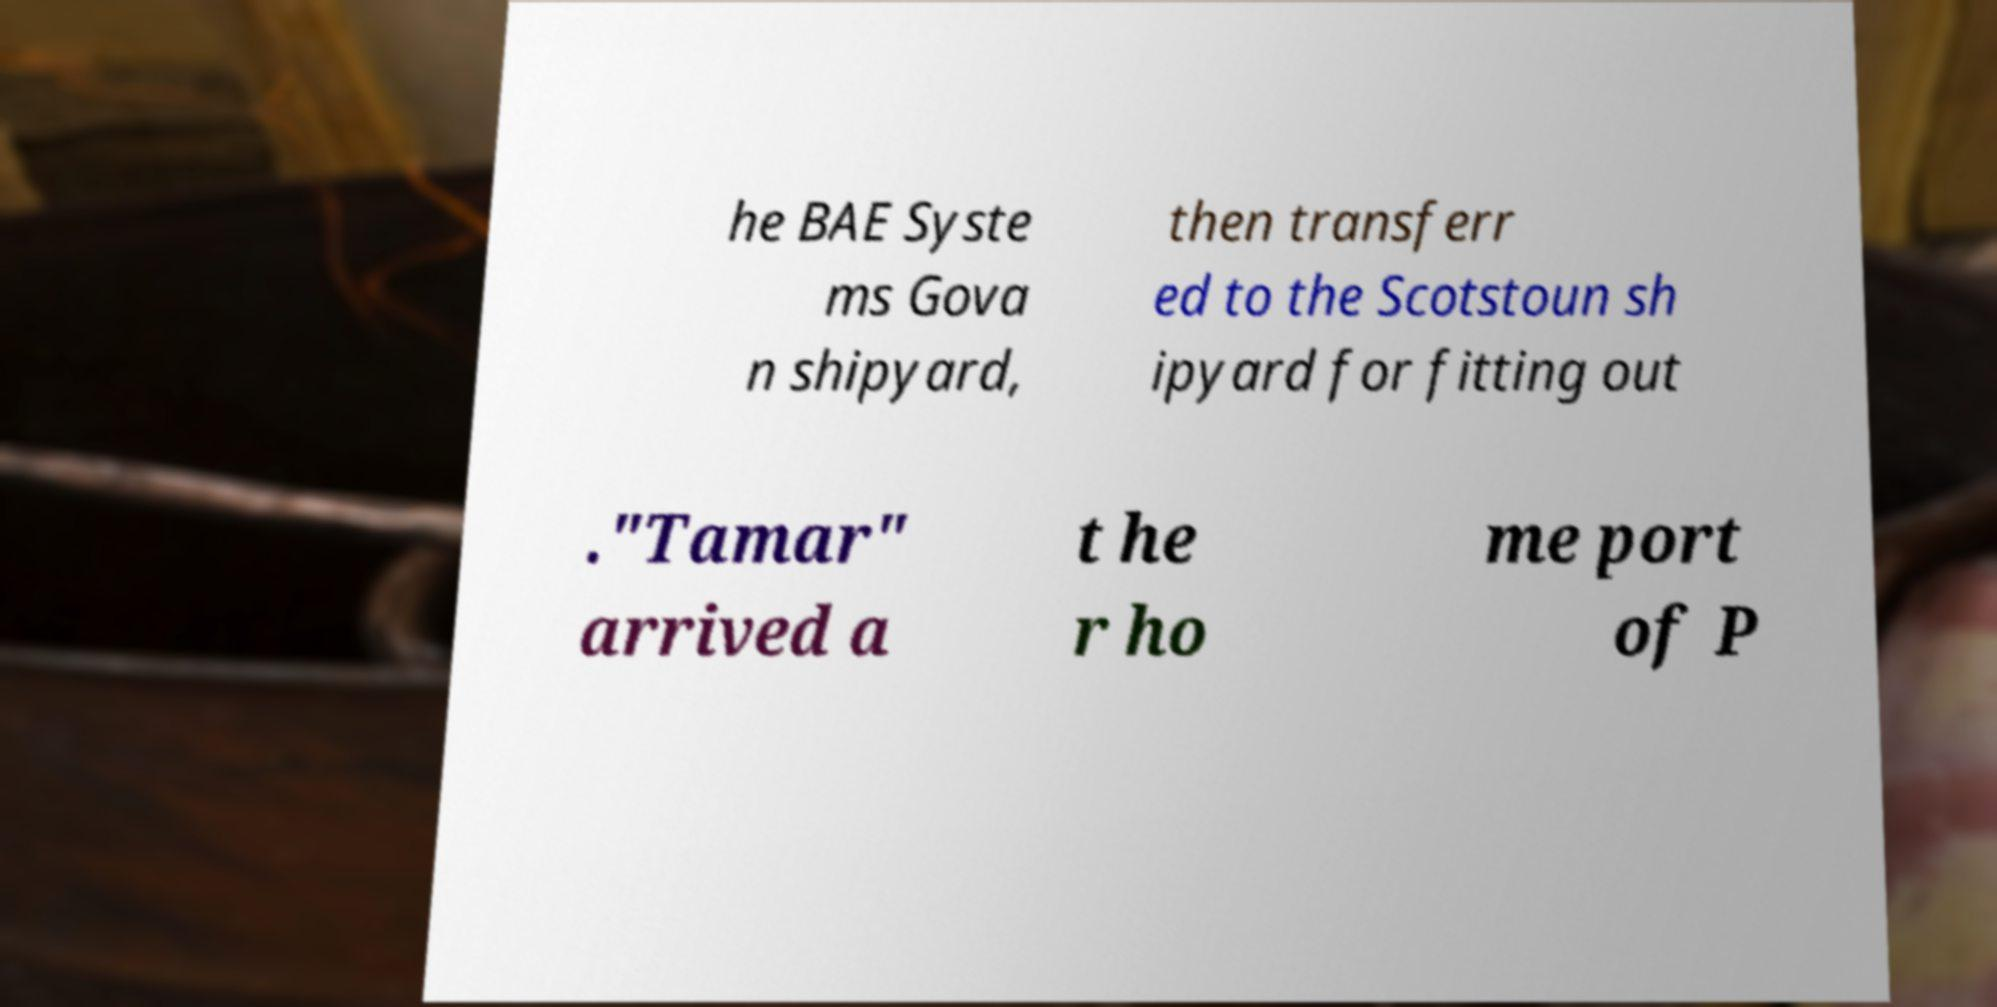Could you assist in decoding the text presented in this image and type it out clearly? he BAE Syste ms Gova n shipyard, then transferr ed to the Scotstoun sh ipyard for fitting out ."Tamar" arrived a t he r ho me port of P 